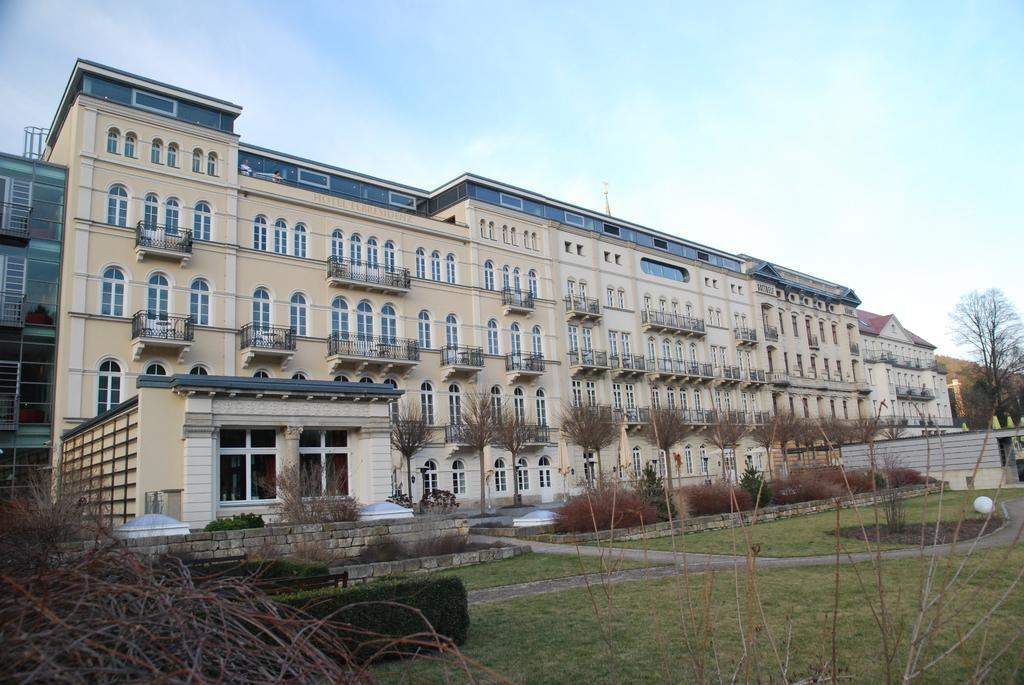In one or two sentences, can you explain what this image depicts? This image consists of buildings along with windows. At the bottom, there is green grass on the ground. On the left. we can see dry grass. On the right, there are trees. At the top, there is sky. 